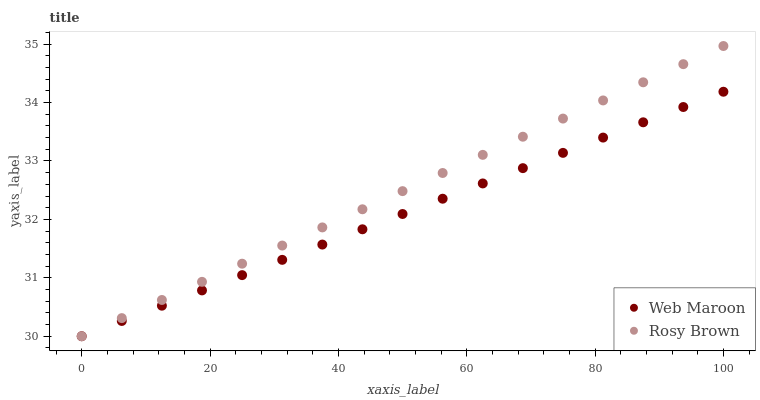Does Web Maroon have the minimum area under the curve?
Answer yes or no. Yes. Does Rosy Brown have the maximum area under the curve?
Answer yes or no. Yes. Does Web Maroon have the maximum area under the curve?
Answer yes or no. No. Is Web Maroon the smoothest?
Answer yes or no. Yes. Is Rosy Brown the roughest?
Answer yes or no. Yes. Is Web Maroon the roughest?
Answer yes or no. No. Does Rosy Brown have the lowest value?
Answer yes or no. Yes. Does Rosy Brown have the highest value?
Answer yes or no. Yes. Does Web Maroon have the highest value?
Answer yes or no. No. Does Rosy Brown intersect Web Maroon?
Answer yes or no. Yes. Is Rosy Brown less than Web Maroon?
Answer yes or no. No. Is Rosy Brown greater than Web Maroon?
Answer yes or no. No. 